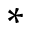<formula> <loc_0><loc_0><loc_500><loc_500>*</formula> 